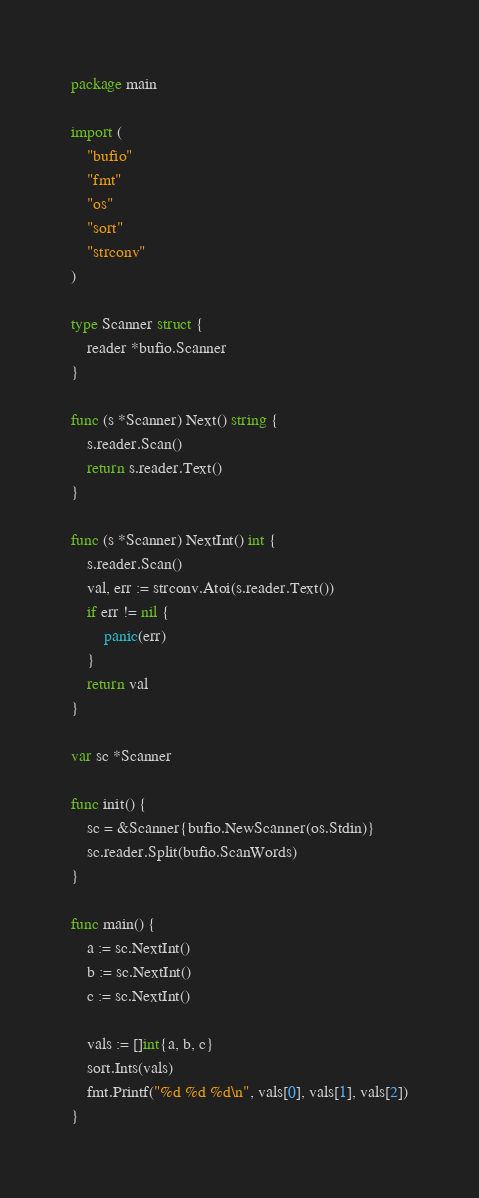Convert code to text. <code><loc_0><loc_0><loc_500><loc_500><_Go_>package main

import (
	"bufio"
	"fmt"
	"os"
	"sort"
	"strconv"
)

type Scanner struct {
	reader *bufio.Scanner
}

func (s *Scanner) Next() string {
	s.reader.Scan()
	return s.reader.Text()
}

func (s *Scanner) NextInt() int {
	s.reader.Scan()
	val, err := strconv.Atoi(s.reader.Text())
	if err != nil {
		panic(err)
	}
	return val
}

var sc *Scanner

func init() {
	sc = &Scanner{bufio.NewScanner(os.Stdin)}
	sc.reader.Split(bufio.ScanWords)
}

func main() {
	a := sc.NextInt()
	b := sc.NextInt()
	c := sc.NextInt()

	vals := []int{a, b, c}
	sort.Ints(vals)
	fmt.Printf("%d %d %d\n", vals[0], vals[1], vals[2])
}

</code> 